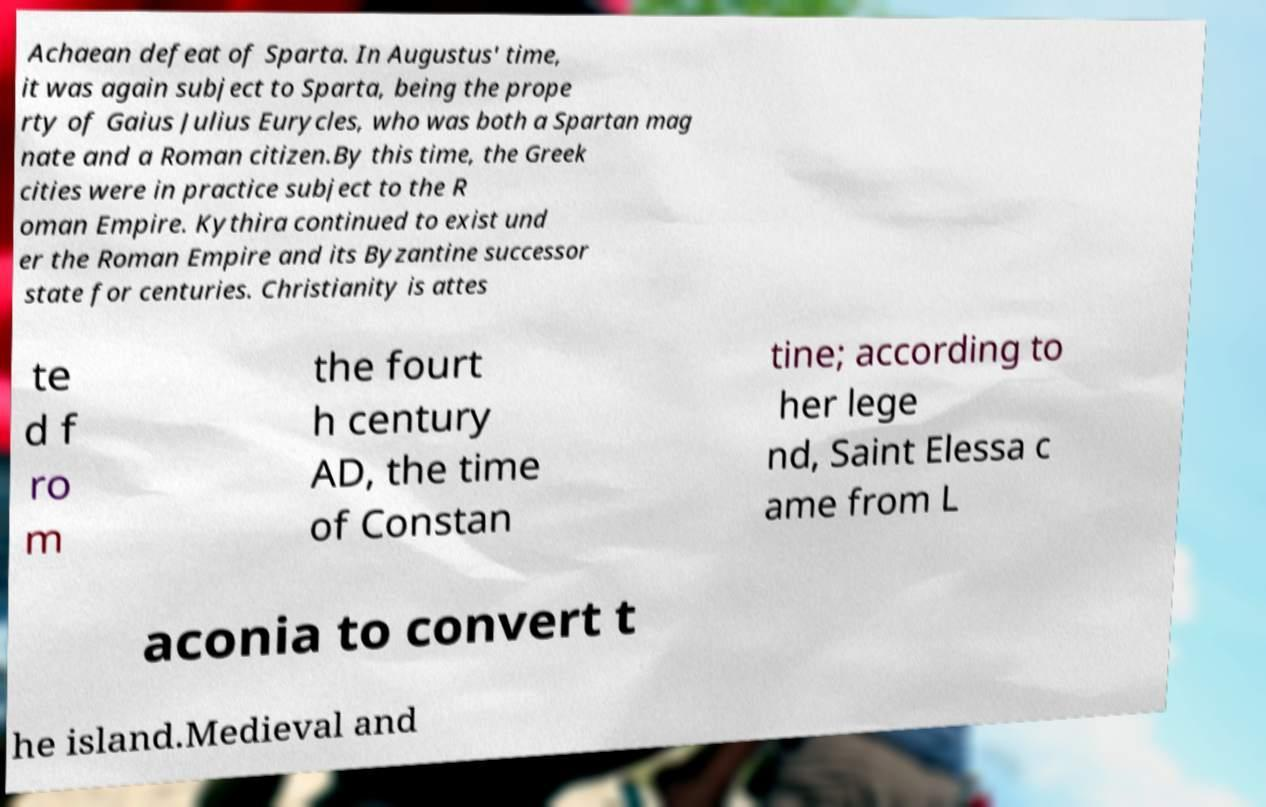Please identify and transcribe the text found in this image. Achaean defeat of Sparta. In Augustus' time, it was again subject to Sparta, being the prope rty of Gaius Julius Eurycles, who was both a Spartan mag nate and a Roman citizen.By this time, the Greek cities were in practice subject to the R oman Empire. Kythira continued to exist und er the Roman Empire and its Byzantine successor state for centuries. Christianity is attes te d f ro m the fourt h century AD, the time of Constan tine; according to her lege nd, Saint Elessa c ame from L aconia to convert t he island.Medieval and 